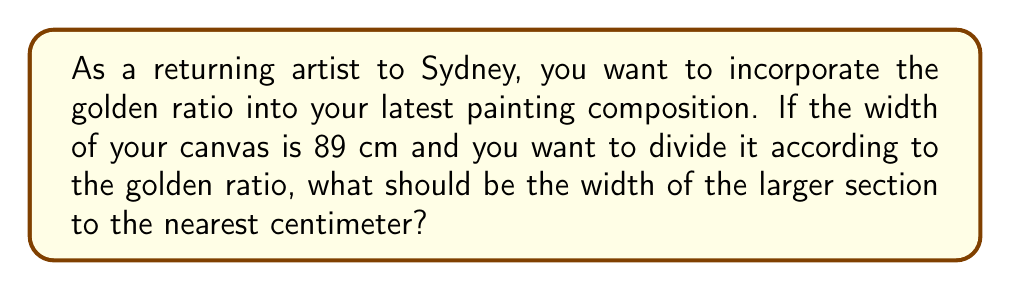Provide a solution to this math problem. Let's approach this step-by-step:

1) The golden ratio, often denoted by the Greek letter φ (phi), is approximately equal to 1.618033988749895.

2) In a golden ratio division, the ratio of the whole to the larger part is equal to the ratio of the larger part to the smaller part.

3) Let's denote the width of the larger section as x. Then, the width of the smaller section will be 89 - x.

4) According to the golden ratio principle:

   $$\frac{89}{x} = \frac{x}{89-x} = φ$$

5) We can solve this equation:

   $$\frac{89}{x} = φ$$
   $$89 = φx$$
   $$x = \frac{89}{φ}$$

6) Substituting the value of φ:

   $$x = \frac{89}{1.618033988749895}$$

7) Calculating this:

   $$x ≈ 55.005 \text{ cm}$$

8) Rounding to the nearest centimeter:

   $$x ≈ 55 \text{ cm}$$

Thus, the larger section should be approximately 55 cm wide.
Answer: 55 cm 